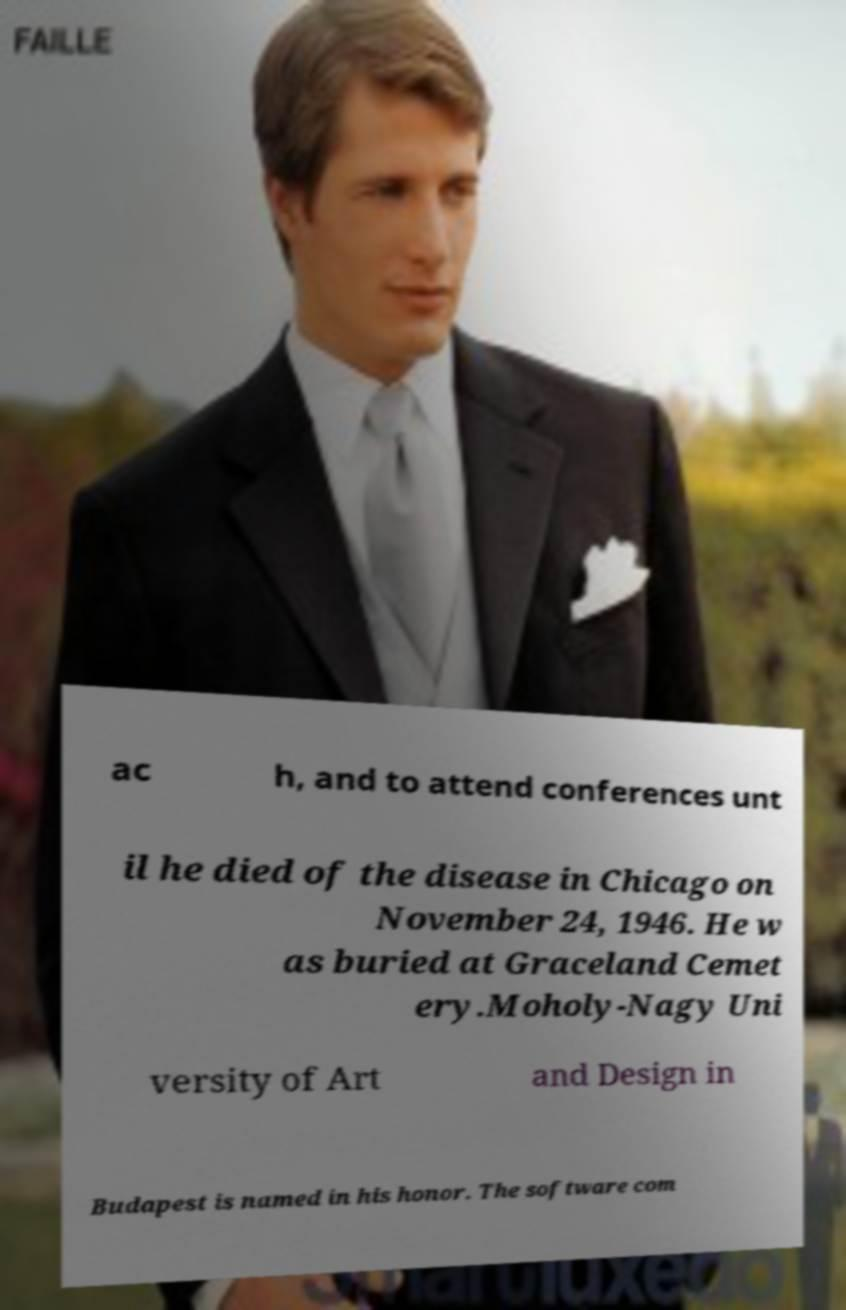Could you extract and type out the text from this image? ac h, and to attend conferences unt il he died of the disease in Chicago on November 24, 1946. He w as buried at Graceland Cemet ery.Moholy-Nagy Uni versity of Art and Design in Budapest is named in his honor. The software com 